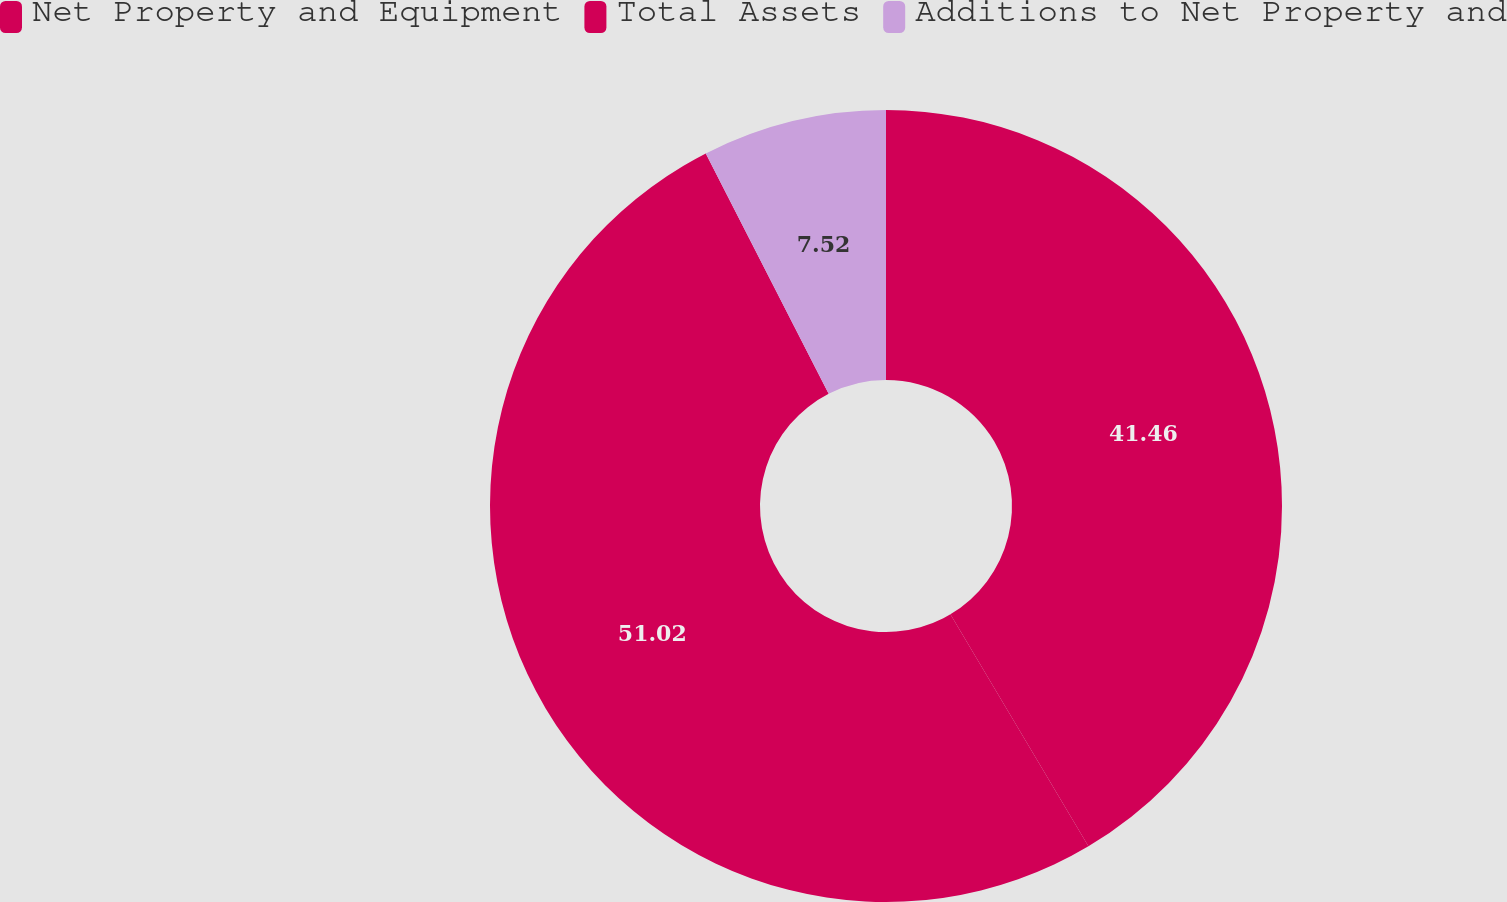<chart> <loc_0><loc_0><loc_500><loc_500><pie_chart><fcel>Net Property and Equipment<fcel>Total Assets<fcel>Additions to Net Property and<nl><fcel>41.46%<fcel>51.02%<fcel>7.52%<nl></chart> 